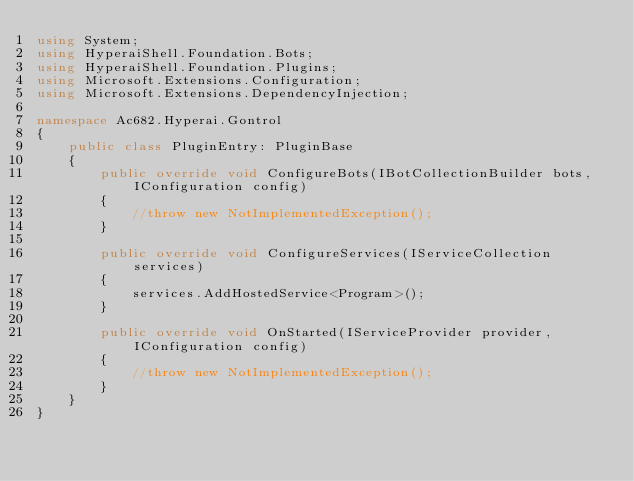<code> <loc_0><loc_0><loc_500><loc_500><_C#_>using System;
using HyperaiShell.Foundation.Bots;
using HyperaiShell.Foundation.Plugins;
using Microsoft.Extensions.Configuration;
using Microsoft.Extensions.DependencyInjection;

namespace Ac682.Hyperai.Gontrol
{
    public class PluginEntry: PluginBase
    {
        public override void ConfigureBots(IBotCollectionBuilder bots, IConfiguration config)
        {
            //throw new NotImplementedException();
        }

        public override void ConfigureServices(IServiceCollection services)
        {
            services.AddHostedService<Program>();
        }

        public override void OnStarted(IServiceProvider provider, IConfiguration config)
        {
            //throw new NotImplementedException();
        }
    }
}</code> 